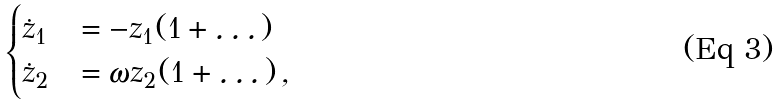<formula> <loc_0><loc_0><loc_500><loc_500>\begin{cases} \dot { z } _ { 1 } & = - z _ { 1 } ( 1 + \dots ) \\ \dot { z } _ { 2 } & = \omega z _ { 2 } ( 1 + \dots ) \, , \end{cases}</formula> 